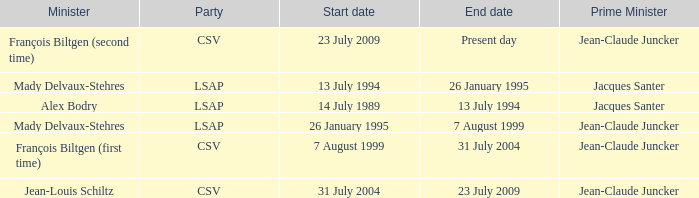What was the end date when Alex Bodry was the minister? 13 July 1994. 